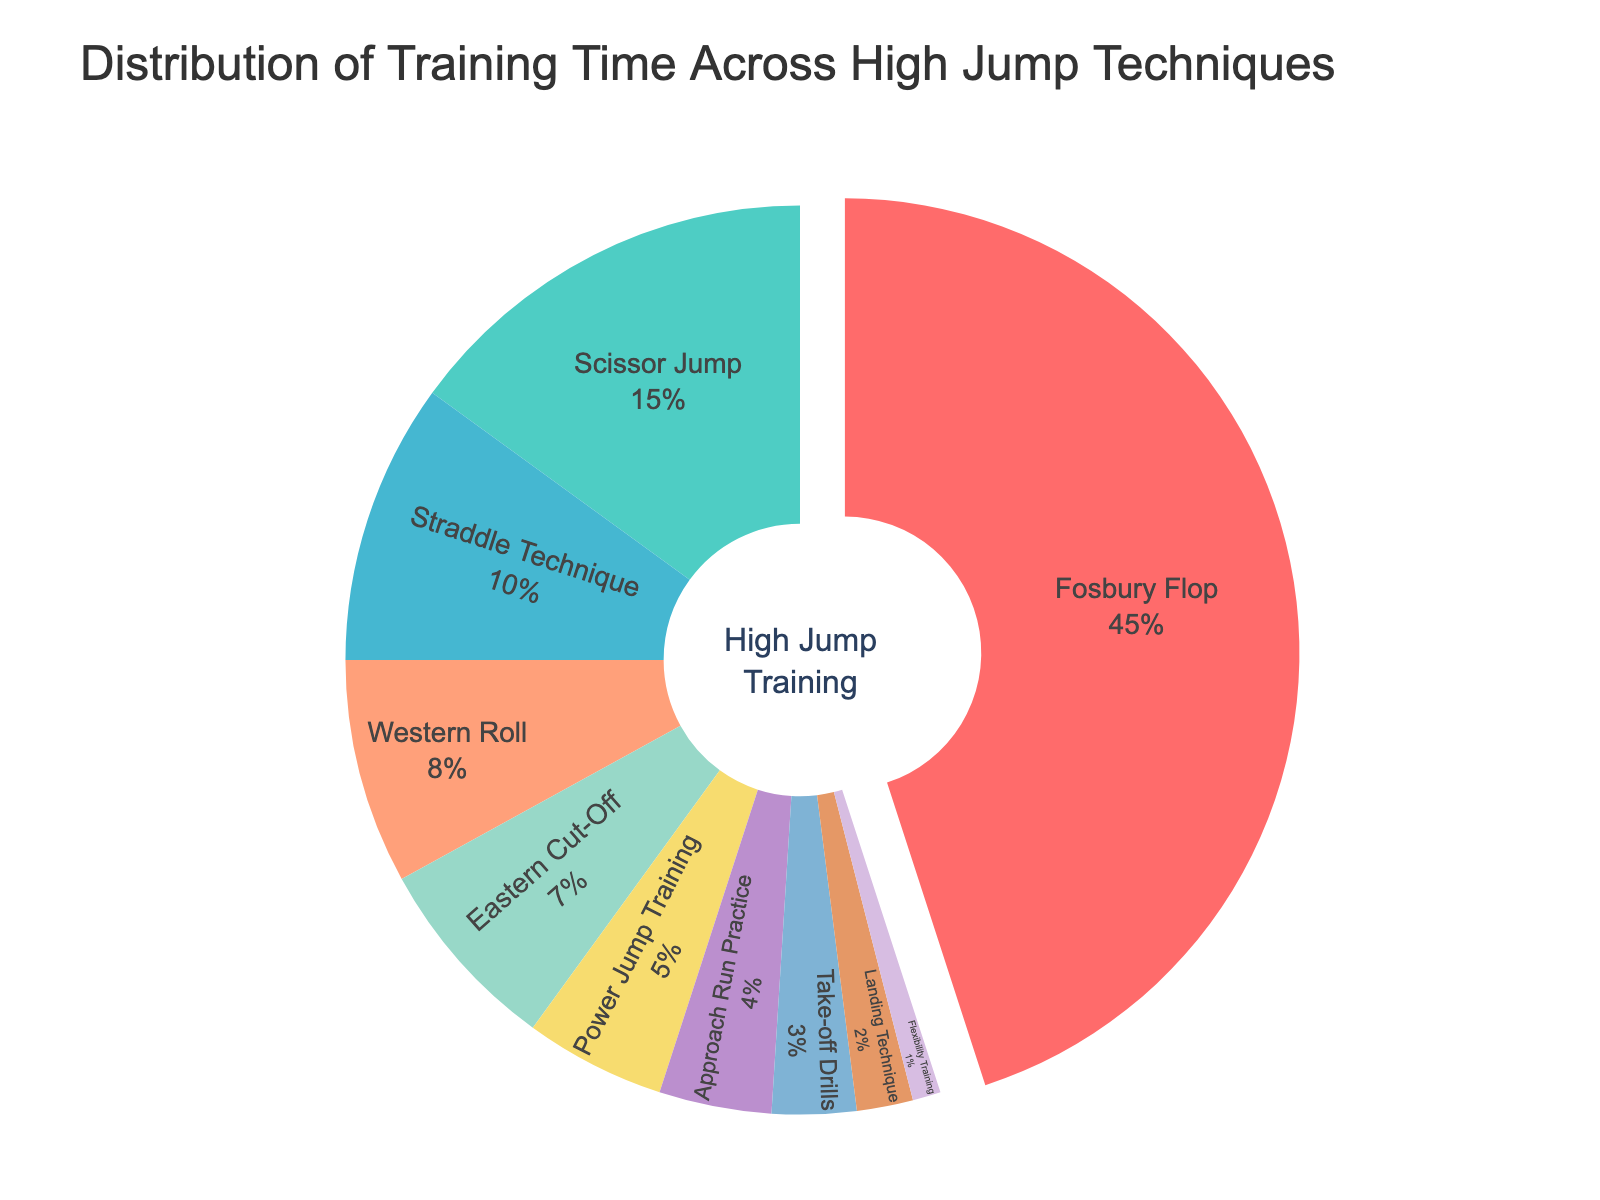What percentage of training time is allocated to techniques other than the Fosbury Flop? The pie chart shows that the Fosbury Flop accounts for 45% of the training time. Adding up the percentages of the other techniques (Scissor Jump, Straddle Technique, Western Roll, Eastern Cut-Off, Power Jump Training, Approach Run Practice, Take-off Drills, Landing Technique, Flexibility Training) gives us 15 + 10 + 8 + 7 + 5 + 4 + 3 + 2 + 1 = 55%.
Answer: 55% Which two techniques together account for a larger percentage of training time: Scissor Jump and Straddle Technique or Western Roll and Eastern Cut-Off? Scissor Jump is 15%, and Straddle Technique is 10%, summing up to 15 + 10 = 25%. Western Roll is 8%, and Eastern Cut-Off is 7%, summing up to 8 + 7 = 15%. Comparing 25% and 15%, the combination of Scissor Jump and Straddle Technique accounts for a larger percentage.
Answer: Scissor Jump and Straddle Technique What is the dominant technique in terms of training time? The pie chart shows that the Fosbury Flop has the largest segment, indicating it takes up the highest percentage of training time at 45%. This is the dominant technique.
Answer: Fosbury Flop How much more time is spent on Scissor Jump training compared to Take-off Drills? The pie chart shows Scissor Jump training is 15%, and Take-off Drills are 3%. The difference is 15% - 3% = 12%.
Answer: 12% Rank the training techniques from most to least based on their percentage allocation. Referring to the pie chart, the percentages are: Fosbury Flop (45%), Scissor Jump (15%), Straddle Technique (10%), Western Roll (8%), Eastern Cut-Off (7%), Power Jump Training (5%), Approach Run Practice (4%), Take-off Drills (3%), Landing Technique (2%), Flexibility Training (1%).
Answer: Fosbury Flop, Scissor Jump, Straddle Technique, Western Roll, Eastern Cut-Off, Power Jump Training, Approach Run Practice, Take-off Drills, Landing Technique, Flexibility Training Which technique has the least training time, and what is its percentage? From the pie chart, we observe that Flexibility Training has the smallest segment, meaning it takes up the least percentage of training time at 1%.
Answer: Flexibility Training, 1% What's the combined percentage of time spent on Approach Run Practice, Take-off Drills, and Landing Technique? The pie chart shows the percentages for Approach Run Practice (4%), Take-off Drills (3%), and Landing Technique (2%). Adding these gives 4 + 3 + 2 = 9%.
Answer: 9% Is there more training time allocated to Power Jump Training or to both Take-off Drills and Flexibility Training combined? The pie chart indicates Power Jump Training accounts for 5%. Take-off Drills account for 3%, and Flexibility Training accounts for 1%. Adding the latter two gives 3 + 1 = 4%. Comparing 5% and 4%, more time is allocated to Power Jump Training.
Answer: Power Jump Training 